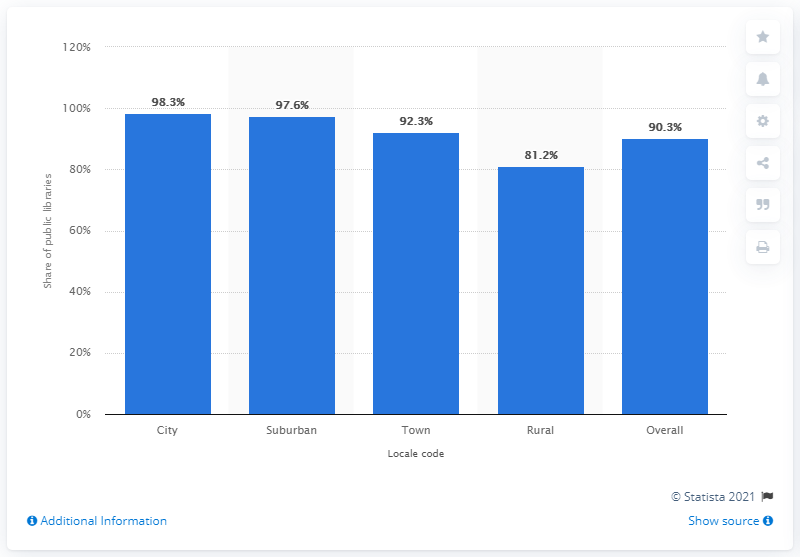Point out several critical features in this image. In 2014, approximately 90.3% of public libraries in the United States offered e-books. 